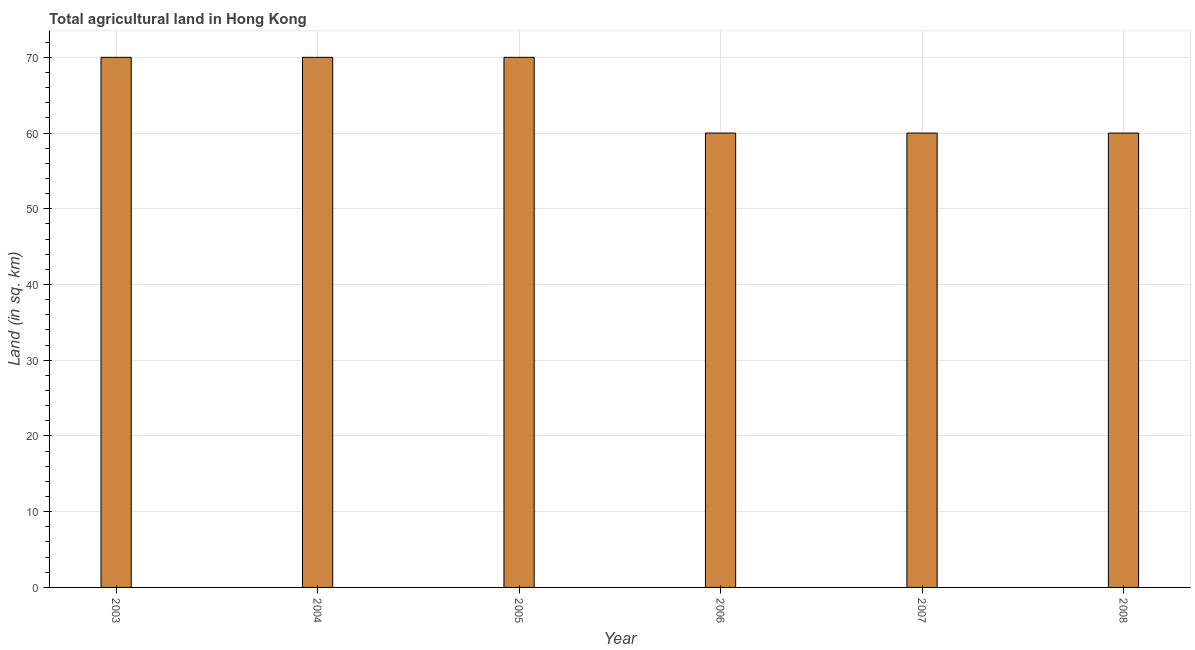Does the graph contain any zero values?
Give a very brief answer. No. Does the graph contain grids?
Your answer should be very brief. Yes. What is the title of the graph?
Make the answer very short. Total agricultural land in Hong Kong. What is the label or title of the Y-axis?
Your response must be concise. Land (in sq. km). Across all years, what is the minimum agricultural land?
Give a very brief answer. 60. What is the sum of the agricultural land?
Offer a terse response. 390. What is the difference between the agricultural land in 2004 and 2007?
Your answer should be very brief. 10. What is the average agricultural land per year?
Ensure brevity in your answer.  65. What is the median agricultural land?
Offer a very short reply. 65. In how many years, is the agricultural land greater than 6 sq. km?
Your answer should be very brief. 6. Do a majority of the years between 2008 and 2006 (inclusive) have agricultural land greater than 4 sq. km?
Your answer should be very brief. Yes. What is the ratio of the agricultural land in 2005 to that in 2007?
Keep it short and to the point. 1.17. Is the agricultural land in 2004 less than that in 2006?
Keep it short and to the point. No. Is the sum of the agricultural land in 2004 and 2005 greater than the maximum agricultural land across all years?
Your response must be concise. Yes. In how many years, is the agricultural land greater than the average agricultural land taken over all years?
Your response must be concise. 3. How many bars are there?
Give a very brief answer. 6. Are all the bars in the graph horizontal?
Provide a succinct answer. No. What is the Land (in sq. km) in 2003?
Your answer should be compact. 70. What is the Land (in sq. km) of 2006?
Make the answer very short. 60. What is the Land (in sq. km) in 2007?
Your answer should be compact. 60. What is the Land (in sq. km) of 2008?
Offer a terse response. 60. What is the difference between the Land (in sq. km) in 2003 and 2004?
Offer a terse response. 0. What is the difference between the Land (in sq. km) in 2003 and 2005?
Your response must be concise. 0. What is the difference between the Land (in sq. km) in 2003 and 2007?
Your answer should be very brief. 10. What is the difference between the Land (in sq. km) in 2004 and 2005?
Your response must be concise. 0. What is the difference between the Land (in sq. km) in 2005 and 2006?
Your response must be concise. 10. What is the difference between the Land (in sq. km) in 2005 and 2007?
Ensure brevity in your answer.  10. What is the difference between the Land (in sq. km) in 2006 and 2007?
Provide a short and direct response. 0. What is the difference between the Land (in sq. km) in 2006 and 2008?
Offer a very short reply. 0. What is the ratio of the Land (in sq. km) in 2003 to that in 2006?
Your response must be concise. 1.17. What is the ratio of the Land (in sq. km) in 2003 to that in 2007?
Give a very brief answer. 1.17. What is the ratio of the Land (in sq. km) in 2003 to that in 2008?
Ensure brevity in your answer.  1.17. What is the ratio of the Land (in sq. km) in 2004 to that in 2006?
Ensure brevity in your answer.  1.17. What is the ratio of the Land (in sq. km) in 2004 to that in 2007?
Keep it short and to the point. 1.17. What is the ratio of the Land (in sq. km) in 2004 to that in 2008?
Your response must be concise. 1.17. What is the ratio of the Land (in sq. km) in 2005 to that in 2006?
Ensure brevity in your answer.  1.17. What is the ratio of the Land (in sq. km) in 2005 to that in 2007?
Offer a terse response. 1.17. What is the ratio of the Land (in sq. km) in 2005 to that in 2008?
Your response must be concise. 1.17. What is the ratio of the Land (in sq. km) in 2006 to that in 2007?
Offer a very short reply. 1. What is the ratio of the Land (in sq. km) in 2006 to that in 2008?
Offer a terse response. 1. What is the ratio of the Land (in sq. km) in 2007 to that in 2008?
Ensure brevity in your answer.  1. 